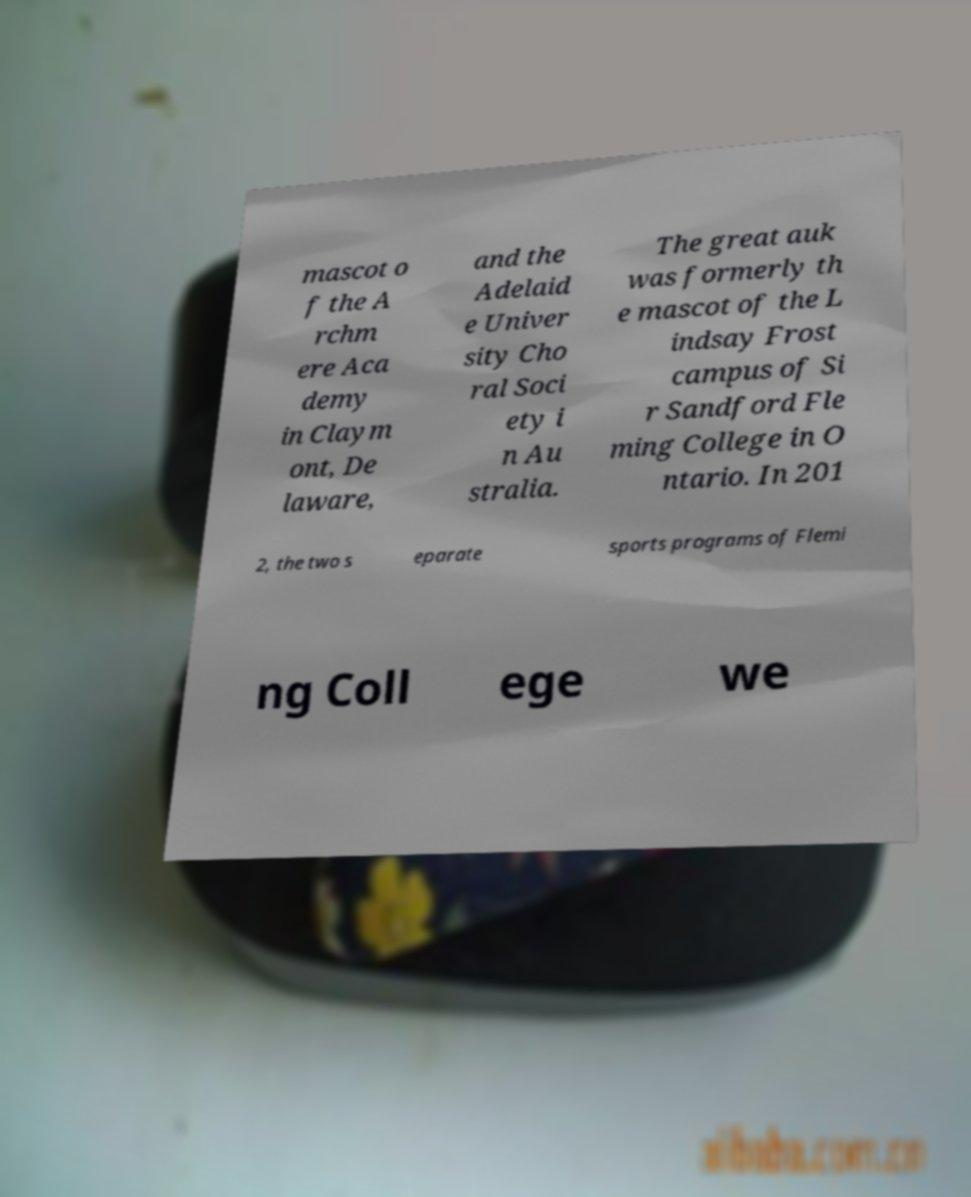Could you assist in decoding the text presented in this image and type it out clearly? mascot o f the A rchm ere Aca demy in Claym ont, De laware, and the Adelaid e Univer sity Cho ral Soci ety i n Au stralia. The great auk was formerly th e mascot of the L indsay Frost campus of Si r Sandford Fle ming College in O ntario. In 201 2, the two s eparate sports programs of Flemi ng Coll ege we 